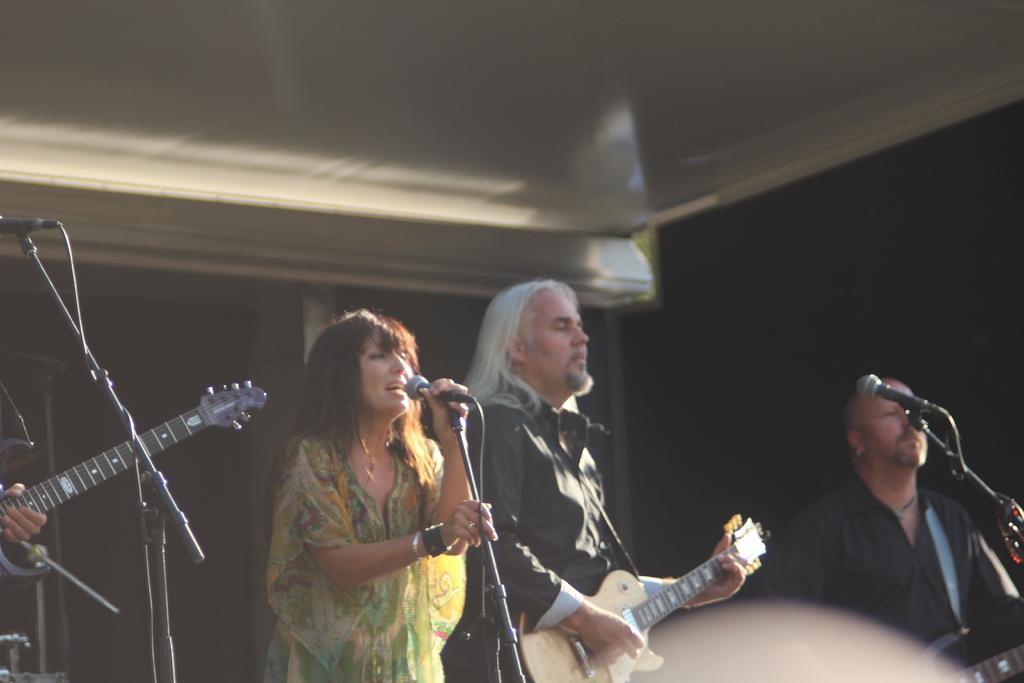Please provide a concise description of this image. In this image, there is a lady in front of the image she is singing in the mice and there is a man behind the lady his playing the guitar and there is a man at the right side of the image playing the drum the man who us left side of the image is playing the guitar, there is a mice on the stage it seems to be a music event. 